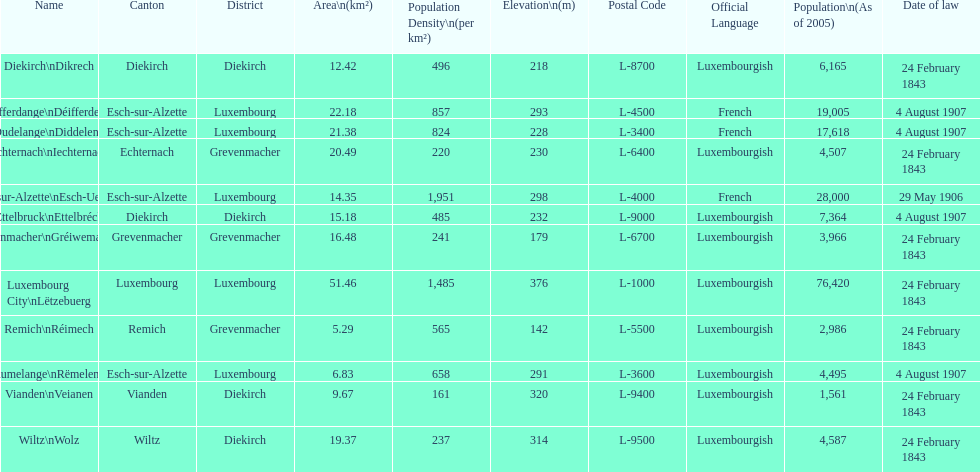How many luxembourg cities had a date of law of feb 24, 1843? 7. 